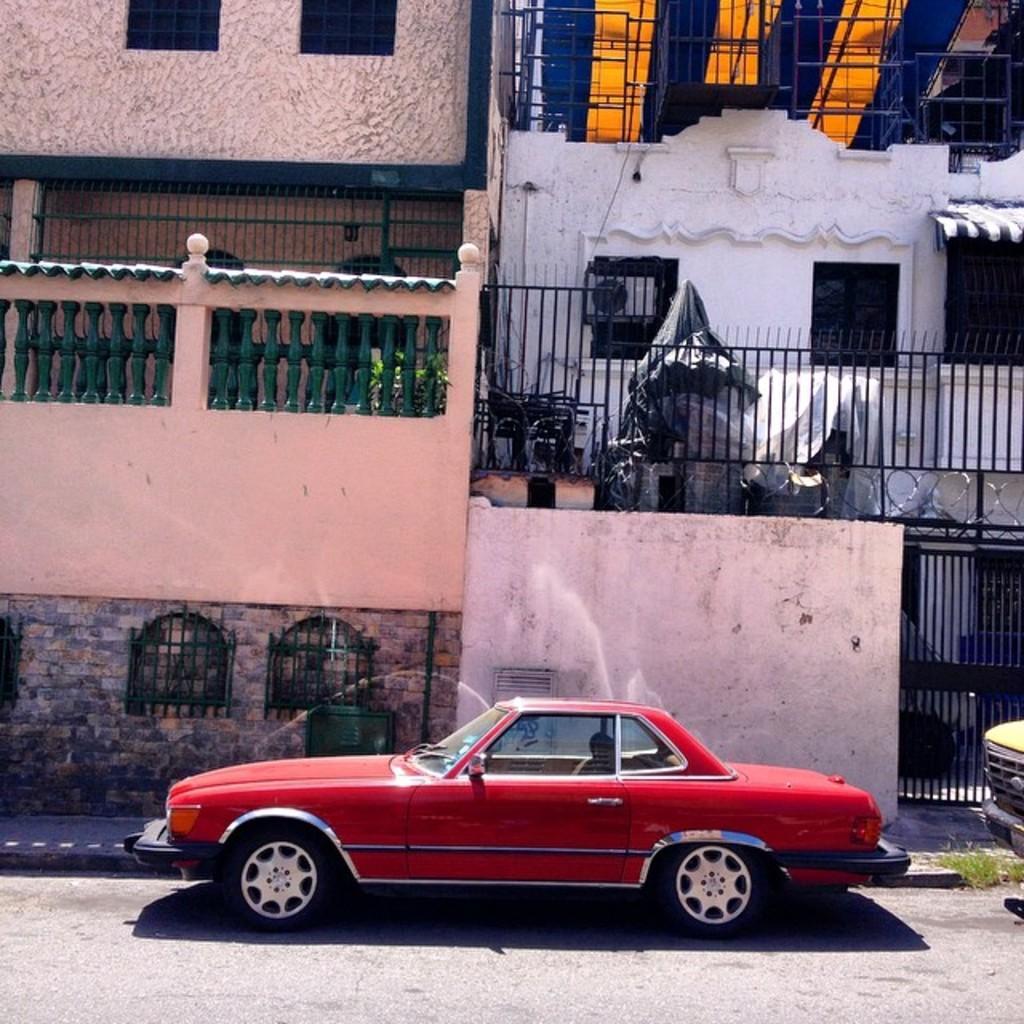Can you describe this image briefly? In this image we can see the buildings, there are some windows, grille and the wall, also we can see the vehicles on the ground. 